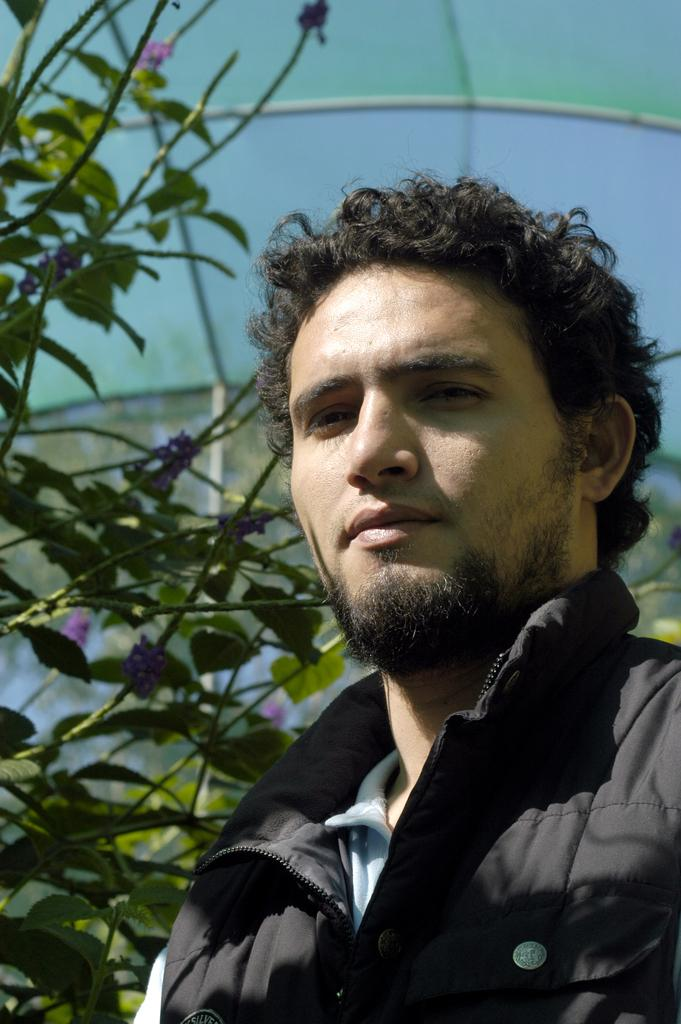What is present in the image? There is a person in the image. What can be seen in the background of the image? There are plants in the background of the image. How many planes are flying over the person in the image? There are no planes visible in the image; it only features a person and plants in the background. 